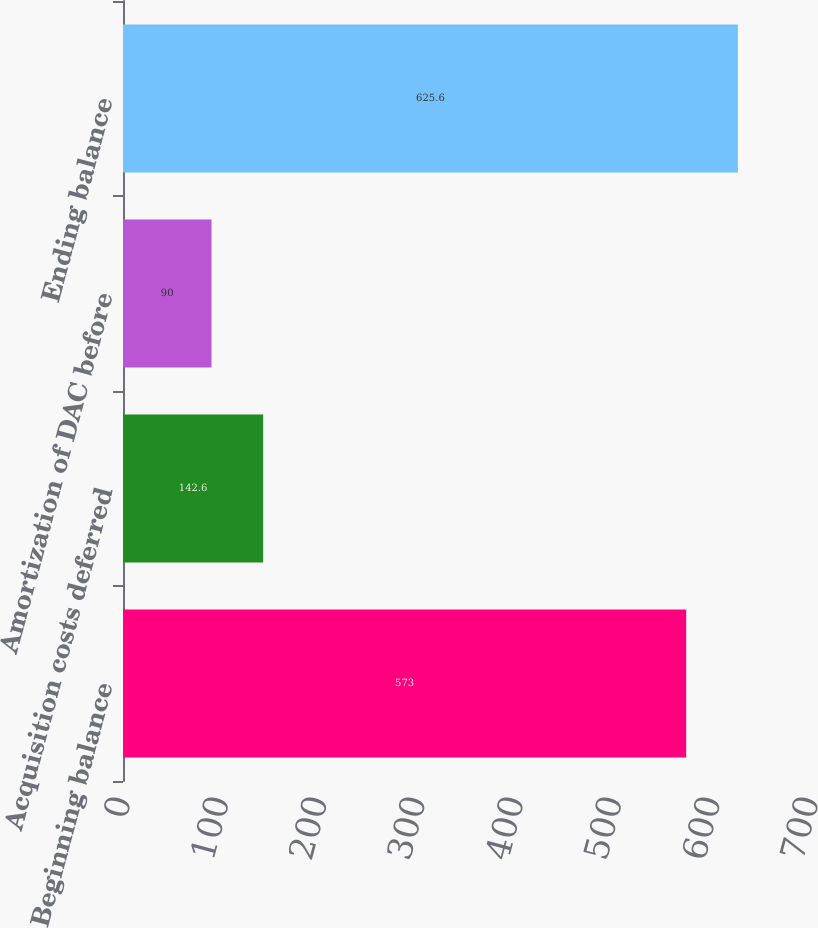<chart> <loc_0><loc_0><loc_500><loc_500><bar_chart><fcel>Beginning balance<fcel>Acquisition costs deferred<fcel>Amortization of DAC before<fcel>Ending balance<nl><fcel>573<fcel>142.6<fcel>90<fcel>625.6<nl></chart> 